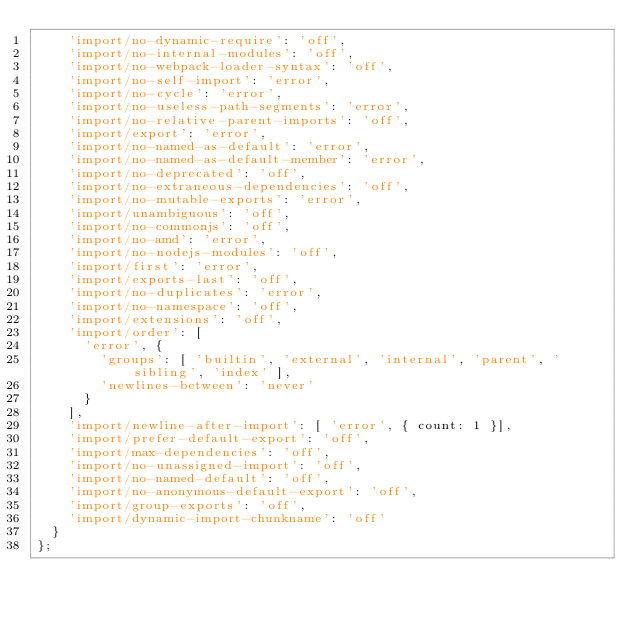Convert code to text. <code><loc_0><loc_0><loc_500><loc_500><_JavaScript_>    'import/no-dynamic-require': 'off',
    'import/no-internal-modules': 'off',
    'import/no-webpack-loader-syntax': 'off',
    'import/no-self-import': 'error',
    'import/no-cycle': 'error',
    'import/no-useless-path-segments': 'error',
    'import/no-relative-parent-imports': 'off',
    'import/export': 'error',
    'import/no-named-as-default': 'error',
    'import/no-named-as-default-member': 'error',
    'import/no-deprecated': 'off',
    'import/no-extraneous-dependencies': 'off',
    'import/no-mutable-exports': 'error',
    'import/unambiguous': 'off',
    'import/no-commonjs': 'off',
    'import/no-amd': 'error',
    'import/no-nodejs-modules': 'off',
    'import/first': 'error',
    'import/exports-last': 'off',
    'import/no-duplicates': 'error',
    'import/no-namespace': 'off',
    'import/extensions': 'off',
    'import/order': [
      'error', {
        'groups': [ 'builtin', 'external', 'internal', 'parent', 'sibling', 'index' ],
        'newlines-between': 'never'
      }
    ],
    'import/newline-after-import': [ 'error', { count: 1 }],
    'import/prefer-default-export': 'off',
    'import/max-dependencies': 'off',
    'import/no-unassigned-import': 'off',
    'import/no-named-default': 'off',
    'import/no-anonymous-default-export': 'off',
    'import/group-exports': 'off',
    'import/dynamic-import-chunkname': 'off'
  }
};
</code> 